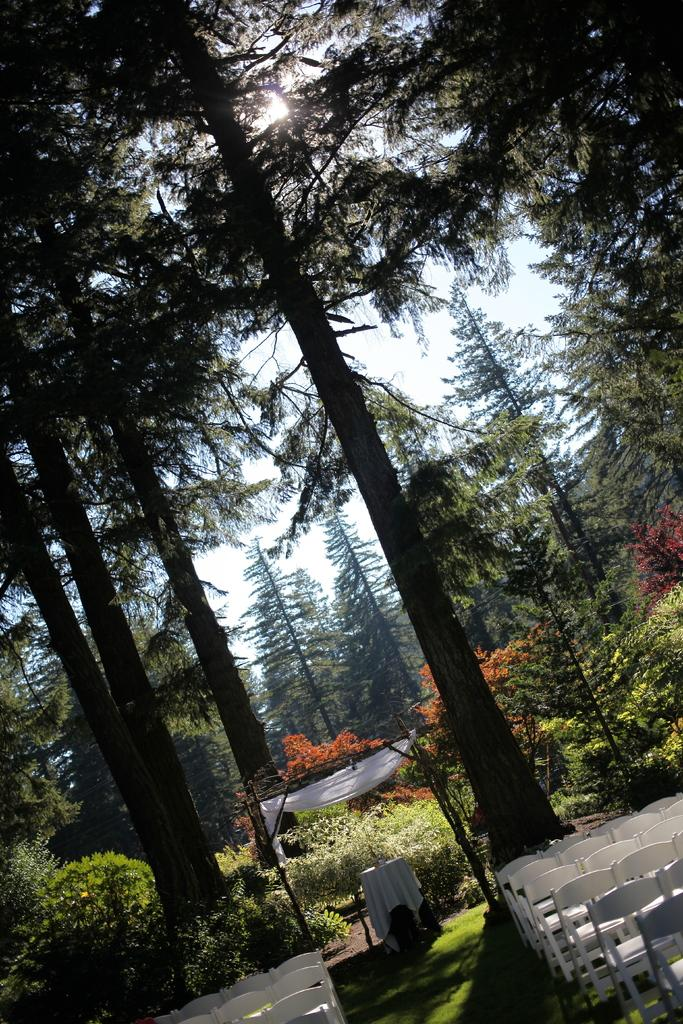What type of furniture is located at the bottom of the image? There are chairs at the bottom of the image. What structure can be seen in the middle of the image? There appears to be a garden shelter in the middle of the image. What type of vegetation is visible in the background of the image? There are trees in the background of the image. What is visible at the top of the image? The sky is visible at the top of the image. How many bikes are parked near the garden shelter in the image? There are no bikes present in the image. What type of discovery was made under the garden shelter in the image? There is no mention of a discovery in the image. 